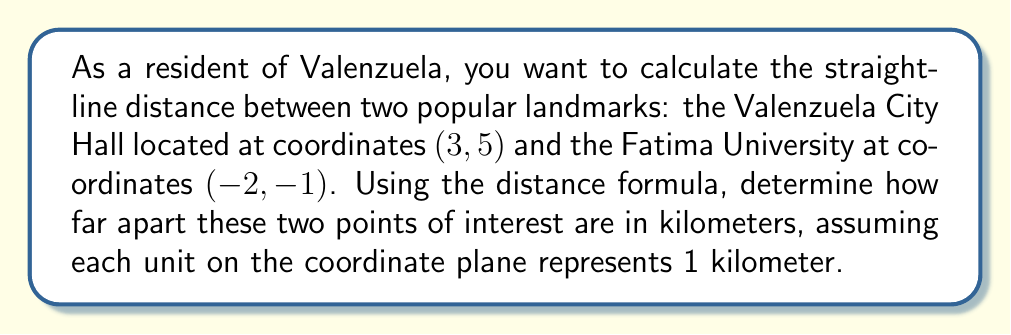Help me with this question. To solve this problem, we'll use the distance formula derived from the Pythagorean theorem:

$$d = \sqrt{(x_2 - x_1)^2 + (y_2 - y_1)^2}$$

Where $(x_1, y_1)$ represents the coordinates of the first point and $(x_2, y_2)$ represents the coordinates of the second point.

Given:
- Valenzuela City Hall: $(x_1, y_1) = (3, 5)$
- Fatima University: $(x_2, y_2) = (-2, -1)$

Let's substitute these values into the formula:

$$d = \sqrt{(-2 - 3)^2 + (-1 - 5)^2}$$

Now, let's solve step by step:

1) Simplify the expressions inside the parentheses:
   $$d = \sqrt{(-5)^2 + (-6)^2}$$

2) Calculate the squares:
   $$d = \sqrt{25 + 36}$$

3) Add the values under the square root:
   $$d = \sqrt{61}$$

4) Simplify the square root:
   $$d \approx 7.81$$

Since each unit represents 1 kilometer, the distance is approximately 7.81 kilometers.
Answer: $7.81$ km 